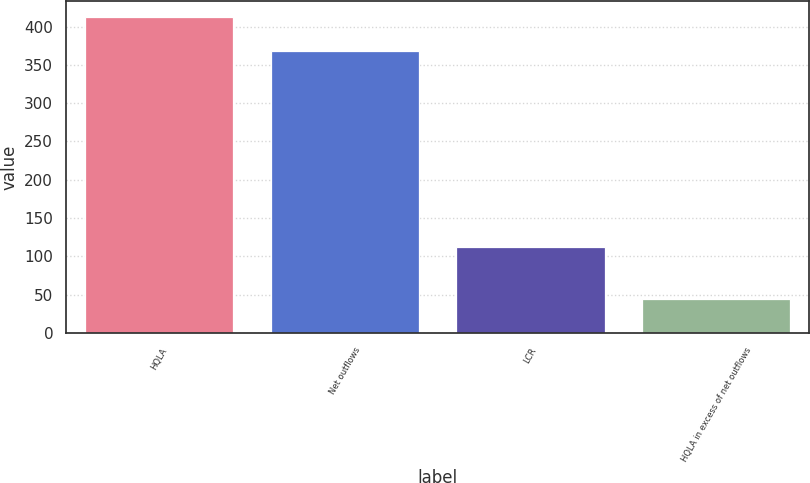<chart> <loc_0><loc_0><loc_500><loc_500><bar_chart><fcel>HQLA<fcel>Net outflows<fcel>LCR<fcel>HQLA in excess of net outflows<nl><fcel>412.6<fcel>368.6<fcel>112<fcel>44<nl></chart> 